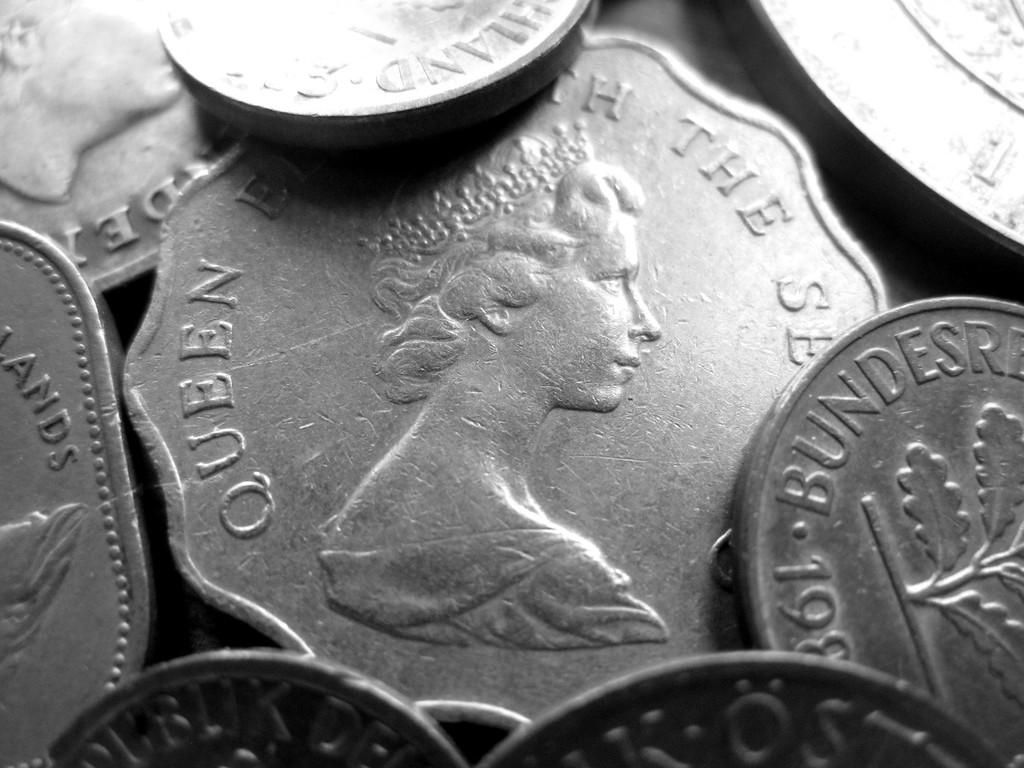<image>
Present a compact description of the photo's key features. An image of a woman and the word Queen are visible on a coin. 